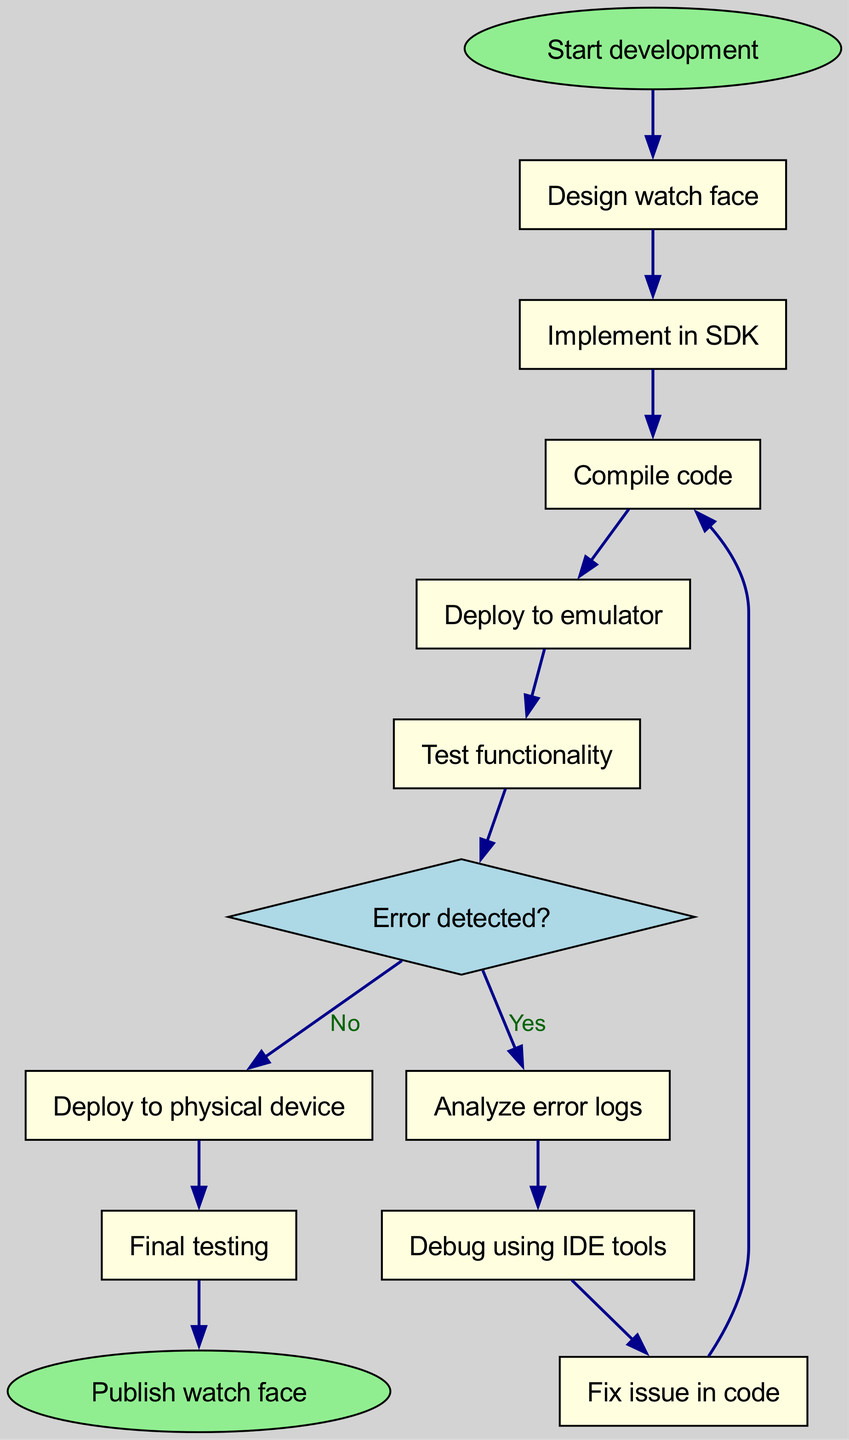What is the first step in the development process? The diagram indicates that the first step in the development process is represented by the node labeled "Start development."
Answer: Start development How many nodes are present in the flowchart? By counting the nodes listed in the data, there are 13 nodes total.
Answer: 13 What node follows "Compile code"? Looking at the edges, the node that follows "Compile code" based on the directed connection is "Deploy to emulator."
Answer: Deploy to emulator Which node represents a decision point? The node labeled "Error detected?" is shaped like a diamond, indicating it is a decision point in the workflow.
Answer: Error detected? If an error is detected, what is the next step? When the flow reaches "Error detected?" and the answer is "Yes," the next step according to the diagram is "Analyze error logs."
Answer: Analyze error logs What happens after reaching "Fix issue in code"? Following "Fix issue in code," the edge connects back to "Compile code," indicating that the workflow loops back for recompilation after making fixes.
Answer: Compile code How many edges are there in the flowchart? By counting the edges listed in the data, there are 12 directed edges that connect the nodes.
Answer: 12 What is the last step in the development process? The last step is represented by the node labeled "Publish watch face," indicating the completion of the workflow.
Answer: Publish watch face What action is taken if no error is detected during testing? If no error is detected, the flow moves directly to "Deploy to physical device."
Answer: Deploy to physical device What is the relationship between "Deploy to emulator" and "Test functionality"? The edge shows a direct connection from "Deploy to emulator" to "Test functionality," indicating that testing follows deployment to the emulator.
Answer: Test functionality 